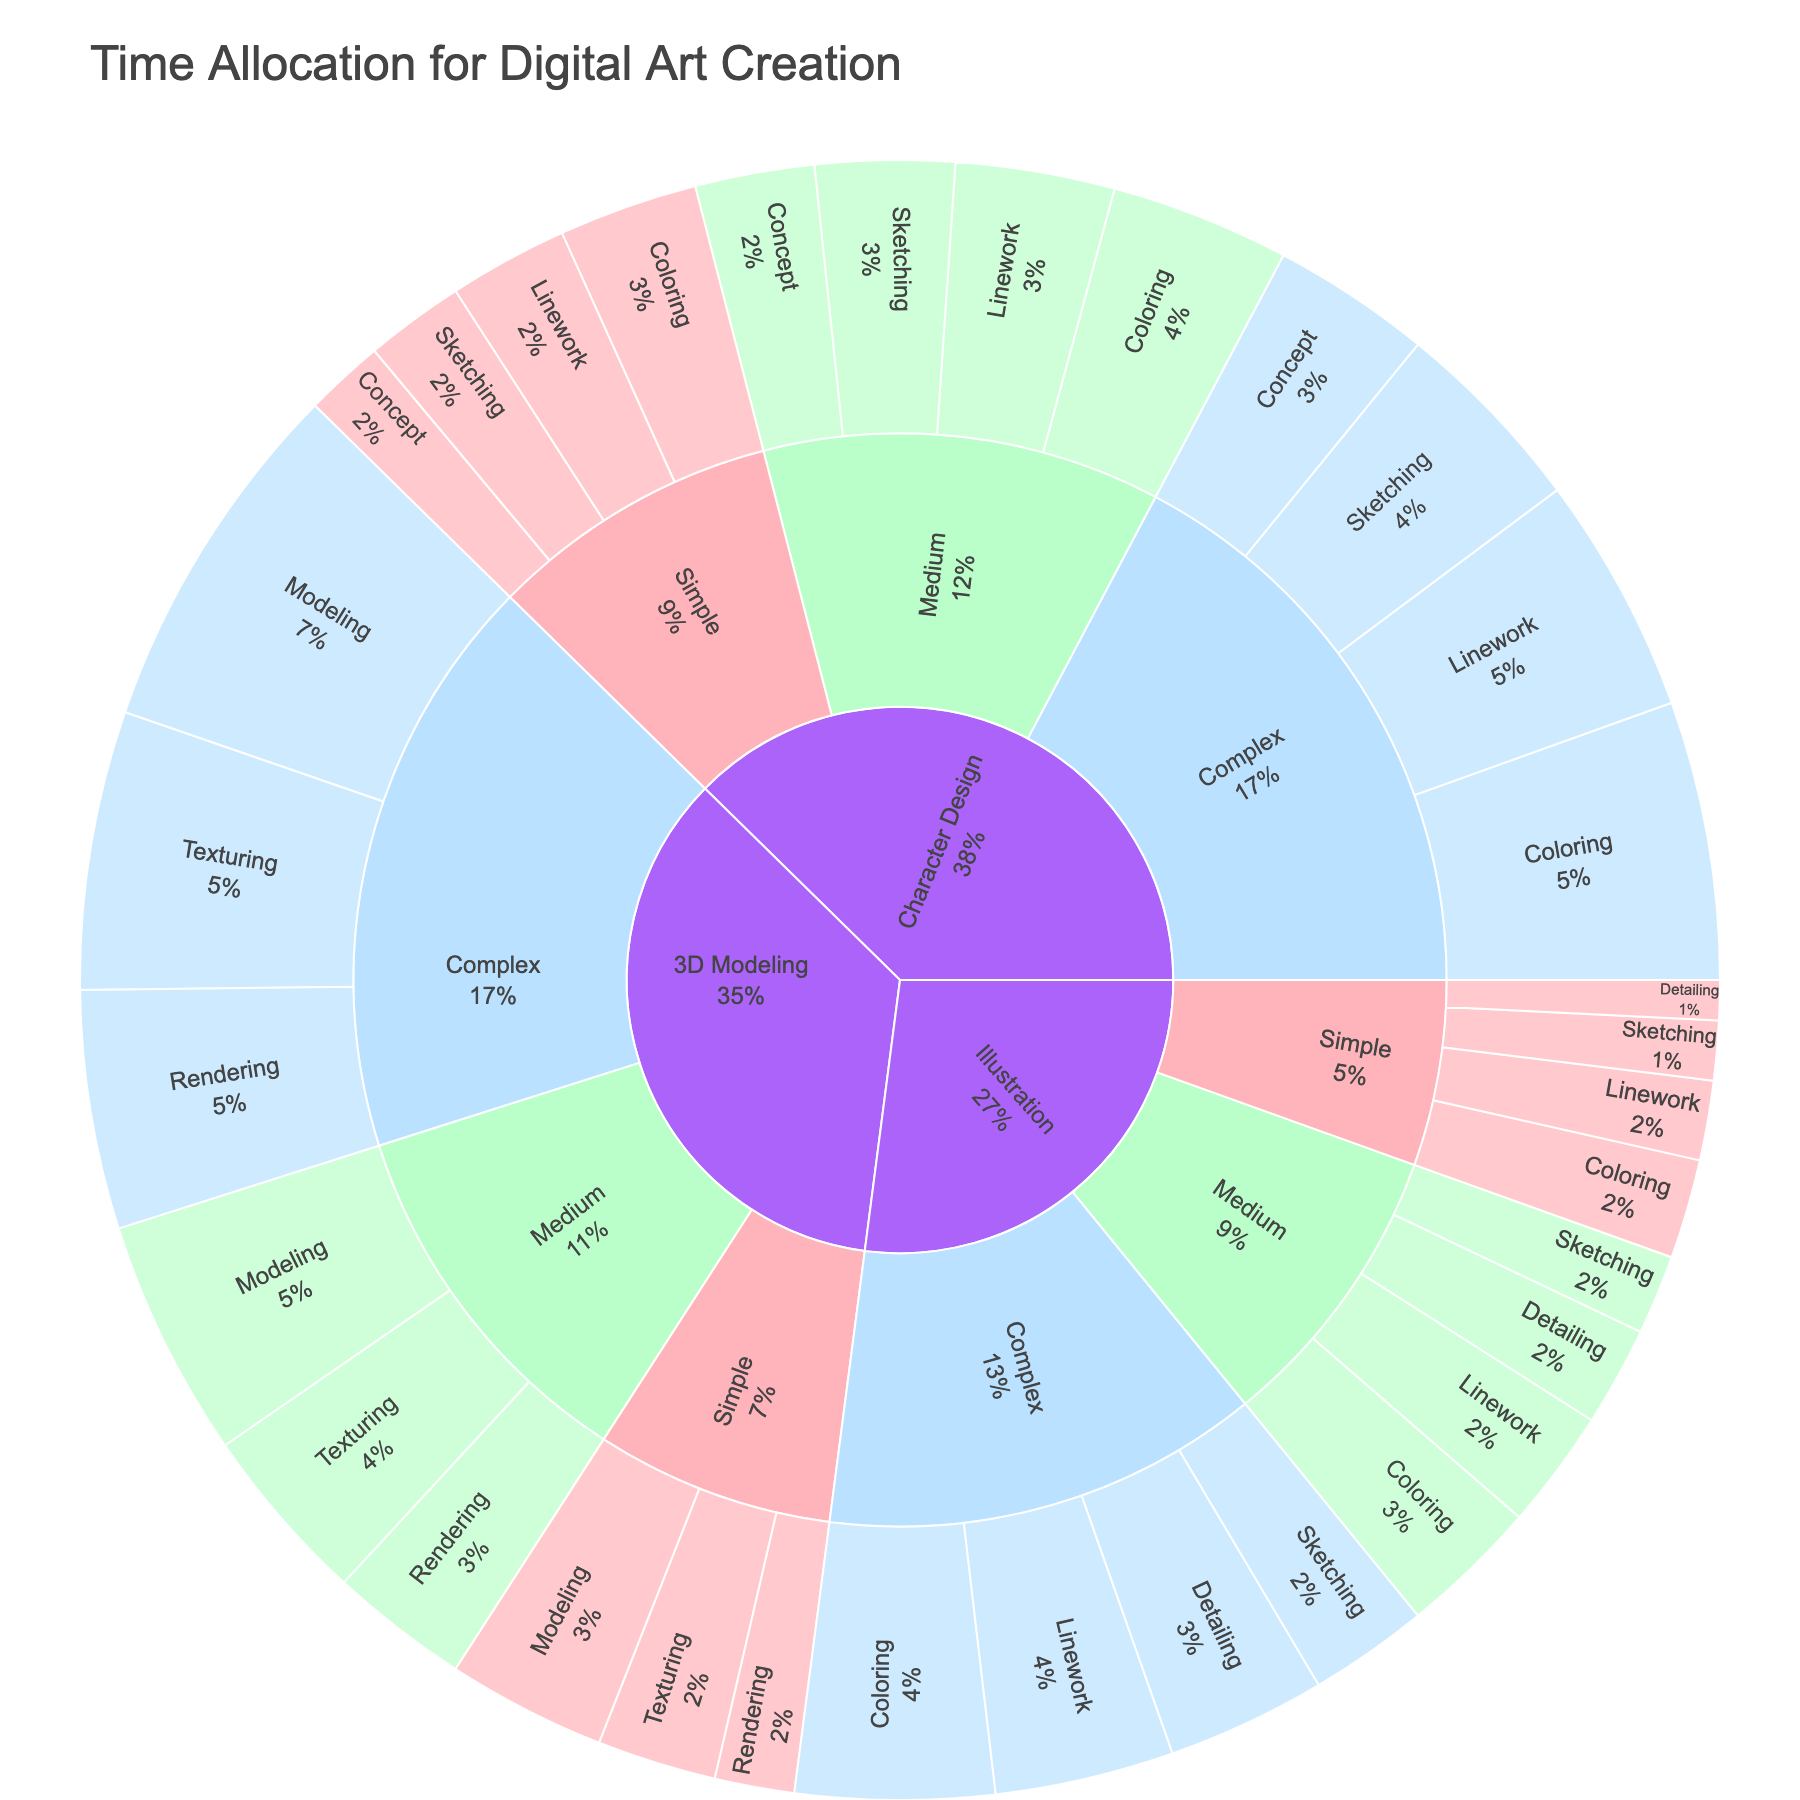What is the title of the Sunburst Plot? The title is located at the top of the plot and provides an overview of what the plot represents.
Answer: Time Allocation for Digital Art Creation Which complexity level has the highest time allocation for Sketching in Character Design projects? Look at the Character Design section in the sunburst plot and compare the time allocations for Sketching across different complexity levels (Simple, Medium, Complex). The Complex level has the highest time allocation for Sketching.
Answer: Complex How does the time allocation for Coloring differ between Simple and Complex 3D Modeling projects? Identify the time allocation for Coloring under Simple (20 hours) and Complex (60 hours) 3D Modeling projects, then subtract the values to find the difference.
Answer: 40 hours difference What percentage of time is allocated to Linework in Medium Illustration compared to the total time allocated for Medium Illustration? Locate the time allocations for all stages under Medium Illustration (20 + 30 + 35 + 25). The time allocation for Linework is 30 hours. Calculate the percentage (30 / total time) * 100.
Answer: 23.8% Which stage consumes the most time in Complex Character Design projects? Look into the Complex Character Design section and observe the time allocations for each stage (Concept, Sketching, Linework, Coloring). The one with the highest value consumes the most time.
Answer: Coloring What is the total time allocated for Medium complexity projects across all project types? Sum the time allocations for Medium complexity from all project types (Illustration, Character Design, 3D Modeling). Add values from the relevant sections.
Answer: 385 hours Which project type has the lowest time allocation for the Detailing stage in Complex projects? In the Complex section for each project type, look at the time allocated for Detailing. Since Detailing doesn't exist in Character Design and 3D Modeling, it’s only present in Illustration, making it the lowest by default.
Answer: Illustration How does the time allocation for Sketching in Simple Illustration compare to Modeling in Simple 3D Modeling? Compare the time values for Sketching in Simple Illustration (15 hours) and Modeling in Simple 3D Modeling (40 hours).
Answer: Sketching is 25 hours less Which project type has the highest overall time allocation for Complex projects? Add up the time allocations for each stage in Complex projects for each project type. The project type with the highest total is the answer.
Answer: Character Design What's the average time allocation for the Coloring stage across all medium complexity projects? Identify the time allocations for Coloring in Medium complexity projects across Illustration, Character Design, and 3D Modeling (35 + 45 + 45). Calculate the average as (35 + 45 + 45) / 3.
Answer: 41.7 hours 